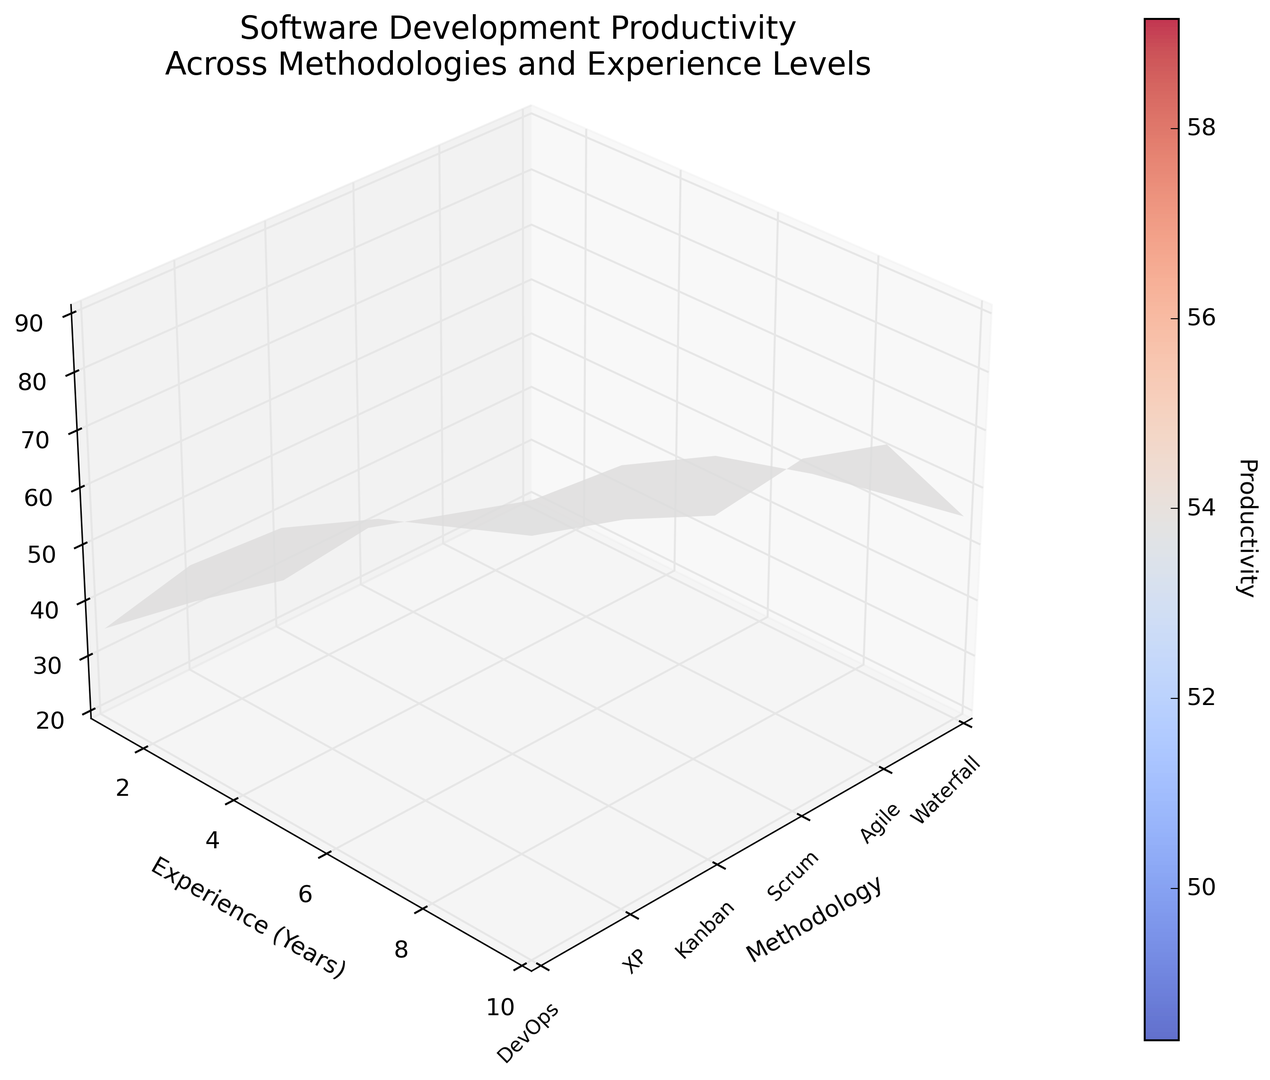What's the highest productivity value for the Kanban methodology? To find the highest productivity value for Kanban, locate the Kanban column and identify the tallest point on the Z-axis. Kanban's highest productivity value corresponds to the experience level of 10 years.
Answer: 78 Which methodology shows the steepest increase in productivity as experience increases? By examining the slopes of each methodology as experience increases, DevOps shows the steepest incline, indicating the most significant increase in productivity with experience.
Answer: DevOps At an experience level of 5 years, which methodology has higher productivity: Agile or Scrum? Locate the 5-year experience level on the Y-axis and compare the productivity values for Agile and Scrum in the Z-axis. Scrum's productivity value at 5 years is higher than Agile's.
Answer: Scrum What is the average productivity of the Waterfall methodology across all experience levels? Sum the productivity values for Waterfall across all experience levels (20 + 35 + 45 + 50 + 55) and divide by the number of points (5). (20 + 35 + 45 + 50 + 55) / 5 = 41
Answer: 41 Compare the productivity difference between XP and DevOps at an experience level of 7 years. Locate the productivity values for XP and DevOps at 7 years on the Z-axis. XP has 78 and DevOps has 80; the difference is 80 - 78.
Answer: 2 Which methodology appears to plateau in productivity at higher experience levels? By checking each methodology's slope in the figure, Waterfall shows a plateau as the productivity increase slows significantly after 7 years.
Answer: Waterfall What is the productivity value for Scrum at an experience level of 3 years? Locate the 3-year experience level on the Y-axis and find the productivity value for Scrum on the Z-axis.
Answer: 50 Which two methodologies have a productivity value of 25 at 1 year of experience? By examining the 1-year experience level, Agile and Kanban both have a productivity value close to 25.
Answer: Agile and Kanban 